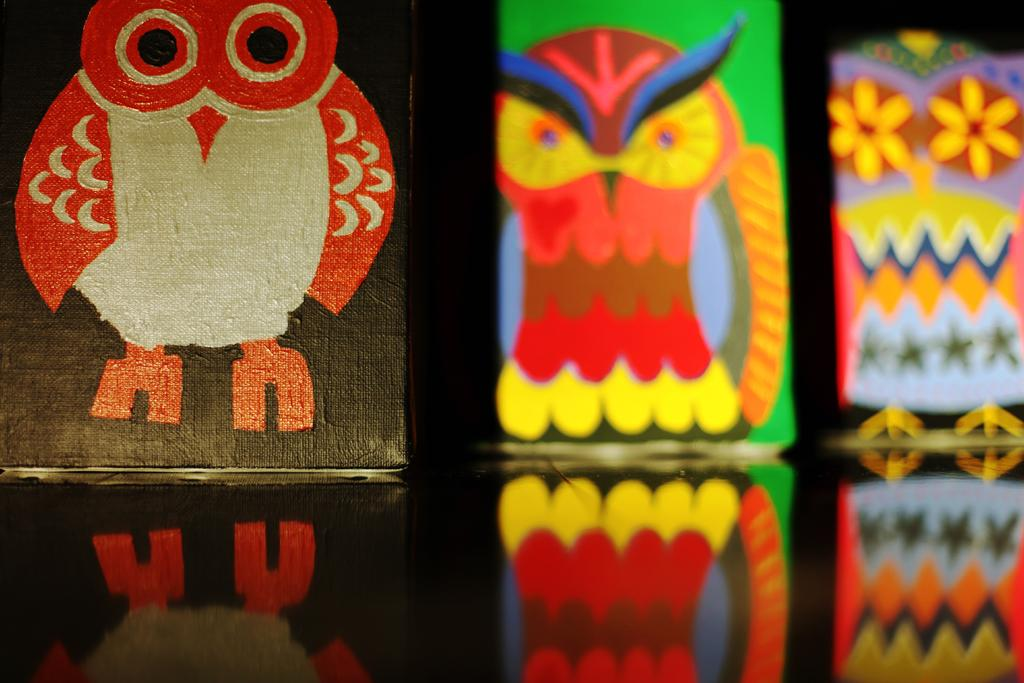What is the main subject of the image? The main subject of the image is three paintings. How are the paintings arranged in the image? The paintings are arranged one after the other. What else can be seen in the image besides the paintings? There are reflections of the paintings visible at the bottom of the image. What type of pan is being used to cook the tax in the image? There is no pan or tax present in the image; it only features three paintings and their reflections. 